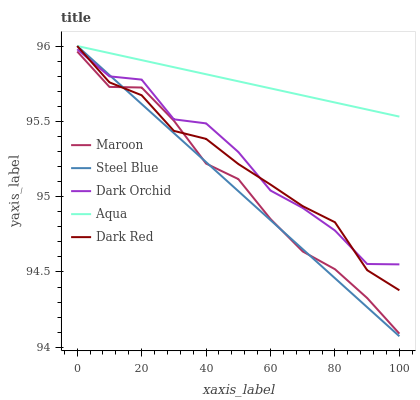Does Steel Blue have the minimum area under the curve?
Answer yes or no. Yes. Does Aqua have the maximum area under the curve?
Answer yes or no. Yes. Does Dark Red have the minimum area under the curve?
Answer yes or no. No. Does Dark Red have the maximum area under the curve?
Answer yes or no. No. Is Aqua the smoothest?
Answer yes or no. Yes. Is Dark Orchid the roughest?
Answer yes or no. Yes. Is Dark Red the smoothest?
Answer yes or no. No. Is Dark Red the roughest?
Answer yes or no. No. Does Steel Blue have the lowest value?
Answer yes or no. Yes. Does Dark Red have the lowest value?
Answer yes or no. No. Does Steel Blue have the highest value?
Answer yes or no. Yes. Does Maroon have the highest value?
Answer yes or no. No. Is Maroon less than Aqua?
Answer yes or no. Yes. Is Dark Orchid greater than Maroon?
Answer yes or no. Yes. Does Dark Red intersect Dark Orchid?
Answer yes or no. Yes. Is Dark Red less than Dark Orchid?
Answer yes or no. No. Is Dark Red greater than Dark Orchid?
Answer yes or no. No. Does Maroon intersect Aqua?
Answer yes or no. No. 